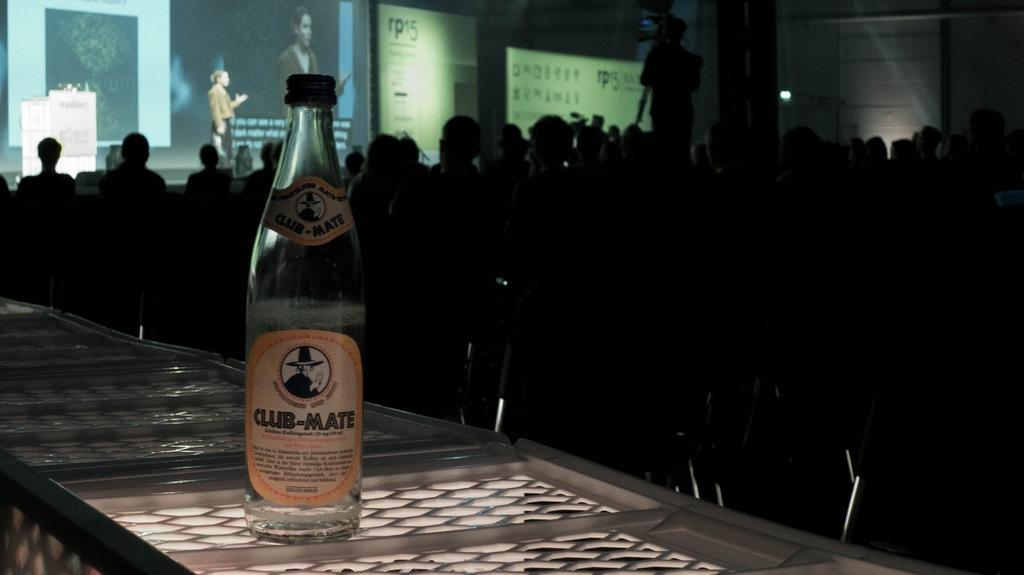What is the main object in the image? There is a wine bottle in the image. Are there any people present in the image? Yes, there are people standing in the image. What type of whistle can be heard coming from the ship in the image? There is no ship or whistle present in the image, so it's not possible to determine what, if any, whistle might be heard. 